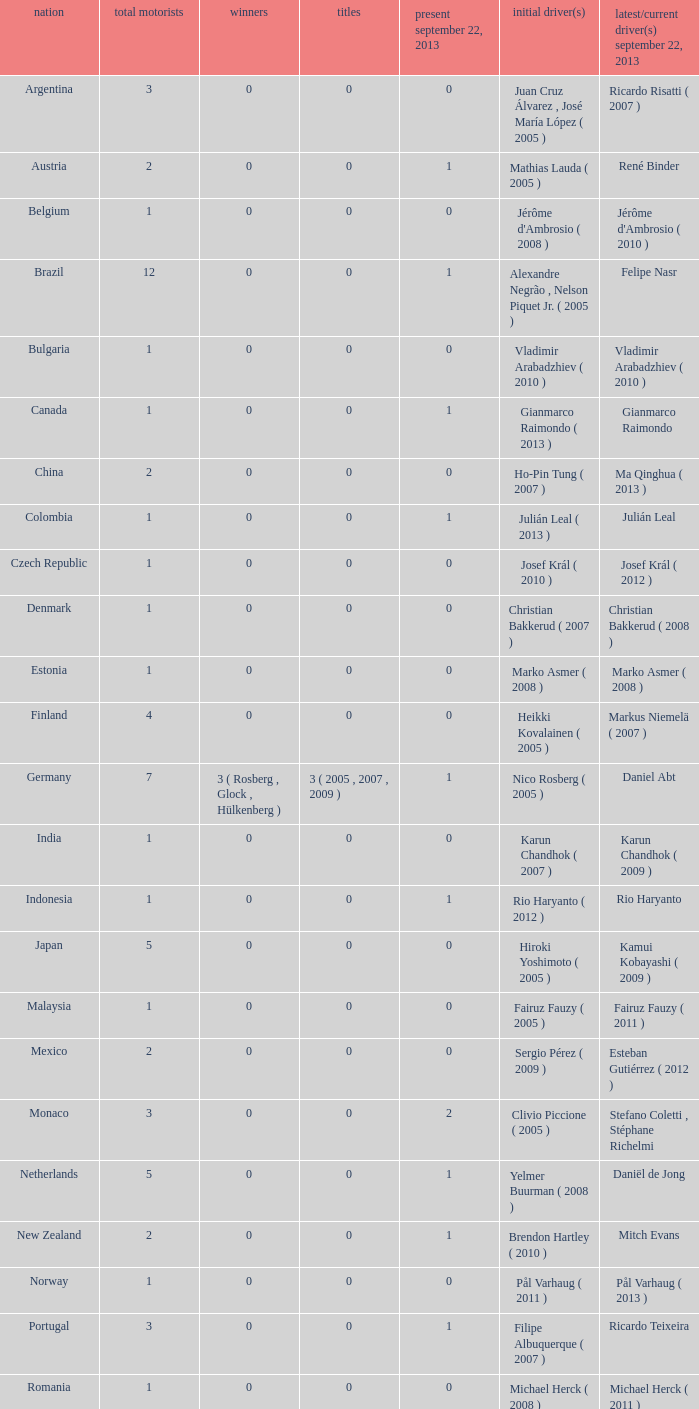How many champions were there when the last driver was Gianmarco Raimondo? 0.0. 